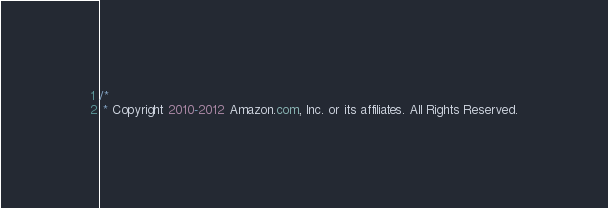Convert code to text. <code><loc_0><loc_0><loc_500><loc_500><_Java_>/*
 * Copyright 2010-2012 Amazon.com, Inc. or its affiliates. All Rights Reserved.</code> 